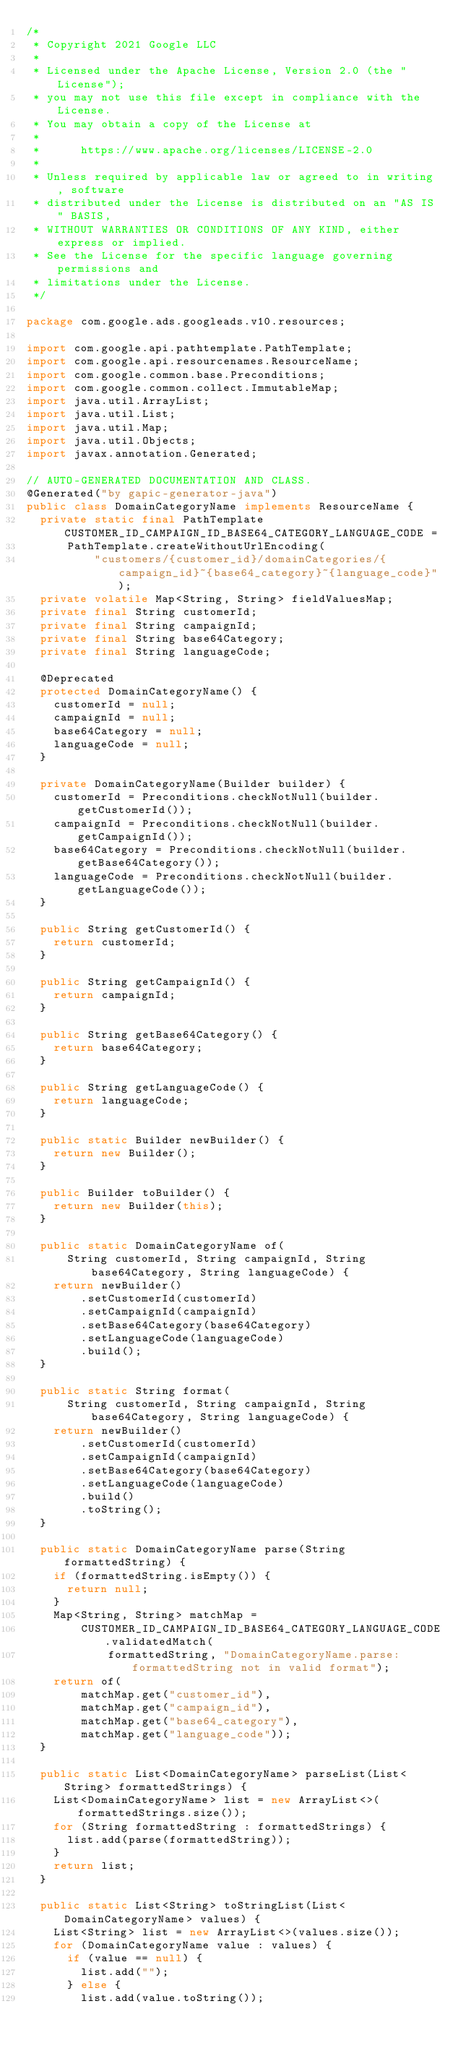Convert code to text. <code><loc_0><loc_0><loc_500><loc_500><_Java_>/*
 * Copyright 2021 Google LLC
 *
 * Licensed under the Apache License, Version 2.0 (the "License");
 * you may not use this file except in compliance with the License.
 * You may obtain a copy of the License at
 *
 *      https://www.apache.org/licenses/LICENSE-2.0
 *
 * Unless required by applicable law or agreed to in writing, software
 * distributed under the License is distributed on an "AS IS" BASIS,
 * WITHOUT WARRANTIES OR CONDITIONS OF ANY KIND, either express or implied.
 * See the License for the specific language governing permissions and
 * limitations under the License.
 */

package com.google.ads.googleads.v10.resources;

import com.google.api.pathtemplate.PathTemplate;
import com.google.api.resourcenames.ResourceName;
import com.google.common.base.Preconditions;
import com.google.common.collect.ImmutableMap;
import java.util.ArrayList;
import java.util.List;
import java.util.Map;
import java.util.Objects;
import javax.annotation.Generated;

// AUTO-GENERATED DOCUMENTATION AND CLASS.
@Generated("by gapic-generator-java")
public class DomainCategoryName implements ResourceName {
  private static final PathTemplate CUSTOMER_ID_CAMPAIGN_ID_BASE64_CATEGORY_LANGUAGE_CODE =
      PathTemplate.createWithoutUrlEncoding(
          "customers/{customer_id}/domainCategories/{campaign_id}~{base64_category}~{language_code}");
  private volatile Map<String, String> fieldValuesMap;
  private final String customerId;
  private final String campaignId;
  private final String base64Category;
  private final String languageCode;

  @Deprecated
  protected DomainCategoryName() {
    customerId = null;
    campaignId = null;
    base64Category = null;
    languageCode = null;
  }

  private DomainCategoryName(Builder builder) {
    customerId = Preconditions.checkNotNull(builder.getCustomerId());
    campaignId = Preconditions.checkNotNull(builder.getCampaignId());
    base64Category = Preconditions.checkNotNull(builder.getBase64Category());
    languageCode = Preconditions.checkNotNull(builder.getLanguageCode());
  }

  public String getCustomerId() {
    return customerId;
  }

  public String getCampaignId() {
    return campaignId;
  }

  public String getBase64Category() {
    return base64Category;
  }

  public String getLanguageCode() {
    return languageCode;
  }

  public static Builder newBuilder() {
    return new Builder();
  }

  public Builder toBuilder() {
    return new Builder(this);
  }

  public static DomainCategoryName of(
      String customerId, String campaignId, String base64Category, String languageCode) {
    return newBuilder()
        .setCustomerId(customerId)
        .setCampaignId(campaignId)
        .setBase64Category(base64Category)
        .setLanguageCode(languageCode)
        .build();
  }

  public static String format(
      String customerId, String campaignId, String base64Category, String languageCode) {
    return newBuilder()
        .setCustomerId(customerId)
        .setCampaignId(campaignId)
        .setBase64Category(base64Category)
        .setLanguageCode(languageCode)
        .build()
        .toString();
  }

  public static DomainCategoryName parse(String formattedString) {
    if (formattedString.isEmpty()) {
      return null;
    }
    Map<String, String> matchMap =
        CUSTOMER_ID_CAMPAIGN_ID_BASE64_CATEGORY_LANGUAGE_CODE.validatedMatch(
            formattedString, "DomainCategoryName.parse: formattedString not in valid format");
    return of(
        matchMap.get("customer_id"),
        matchMap.get("campaign_id"),
        matchMap.get("base64_category"),
        matchMap.get("language_code"));
  }

  public static List<DomainCategoryName> parseList(List<String> formattedStrings) {
    List<DomainCategoryName> list = new ArrayList<>(formattedStrings.size());
    for (String formattedString : formattedStrings) {
      list.add(parse(formattedString));
    }
    return list;
  }

  public static List<String> toStringList(List<DomainCategoryName> values) {
    List<String> list = new ArrayList<>(values.size());
    for (DomainCategoryName value : values) {
      if (value == null) {
        list.add("");
      } else {
        list.add(value.toString());</code> 